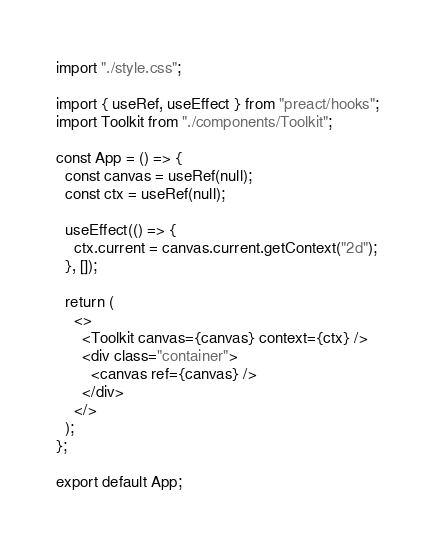Convert code to text. <code><loc_0><loc_0><loc_500><loc_500><_JavaScript_>import "./style.css";

import { useRef, useEffect } from "preact/hooks";
import Toolkit from "./components/Toolkit";

const App = () => {
  const canvas = useRef(null);
  const ctx = useRef(null);

  useEffect(() => {
    ctx.current = canvas.current.getContext("2d");
  }, []);

  return (
    <>
      <Toolkit canvas={canvas} context={ctx} />
      <div class="container">
        <canvas ref={canvas} />
      </div>
    </>
  );
};

export default App;
</code> 